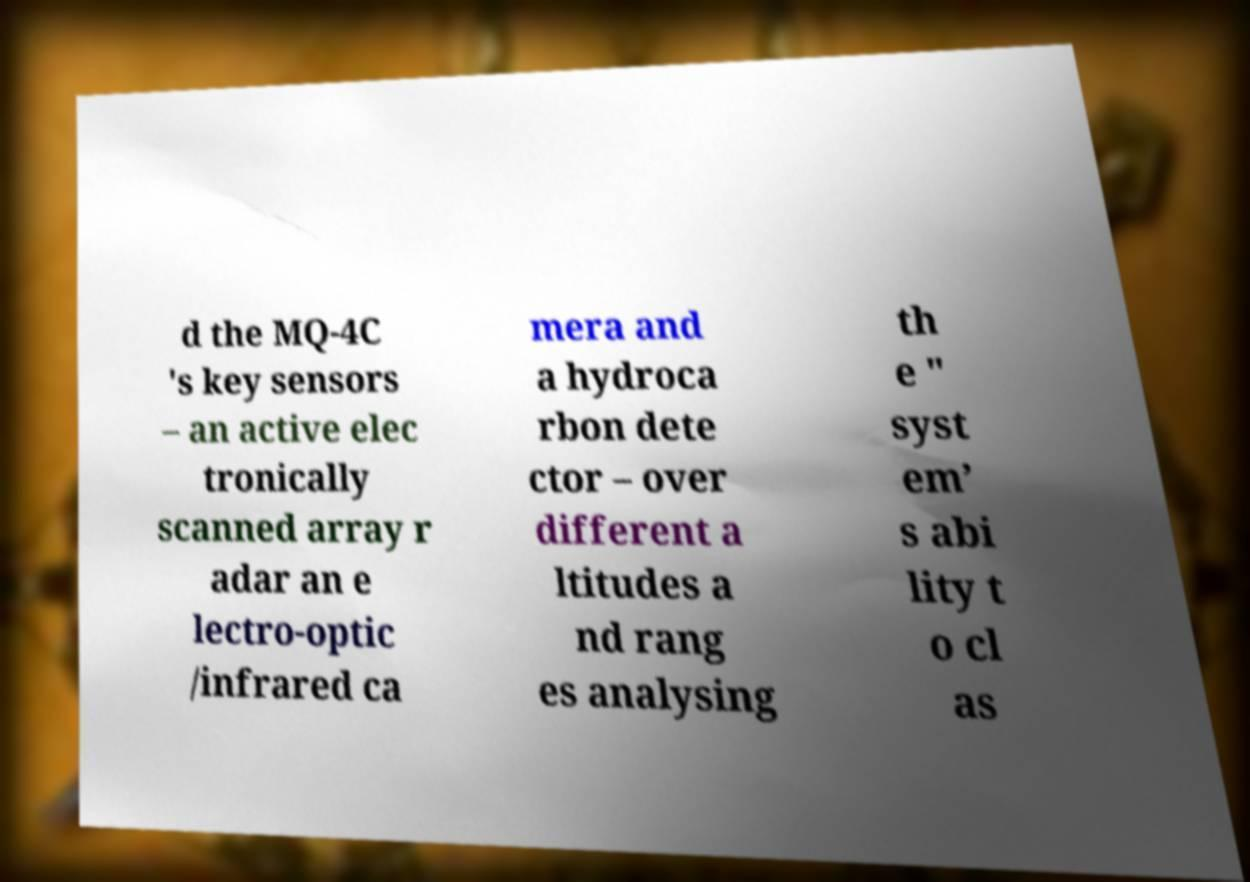What messages or text are displayed in this image? I need them in a readable, typed format. d the MQ-4C 's key sensors – an active elec tronically scanned array r adar an e lectro-optic /infrared ca mera and a hydroca rbon dete ctor – over different a ltitudes a nd rang es analysing th e " syst em’ s abi lity t o cl as 